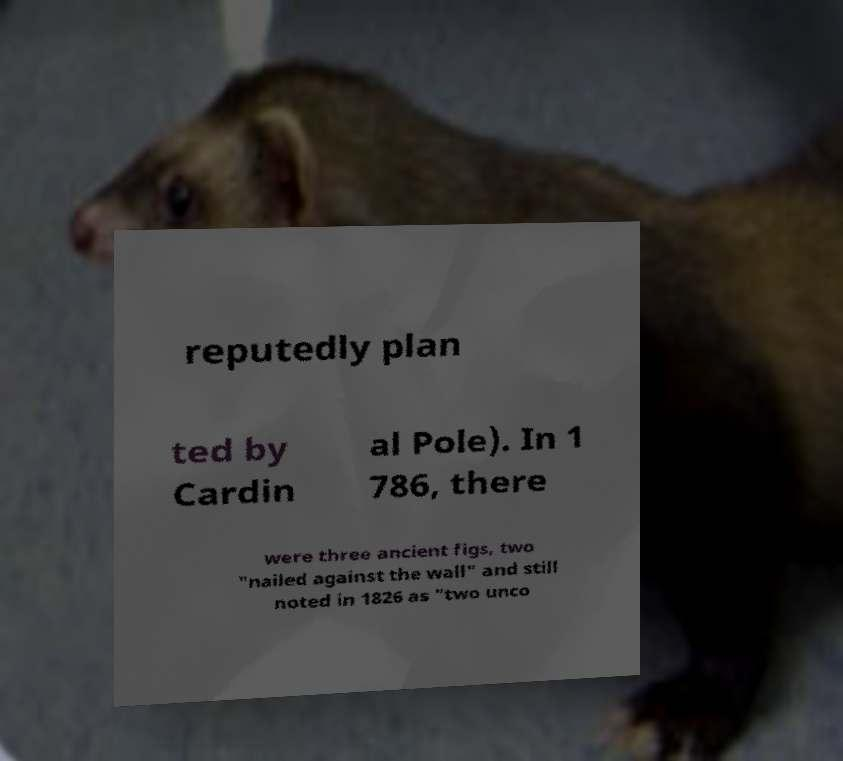Please identify and transcribe the text found in this image. reputedly plan ted by Cardin al Pole). In 1 786, there were three ancient figs, two "nailed against the wall" and still noted in 1826 as "two unco 